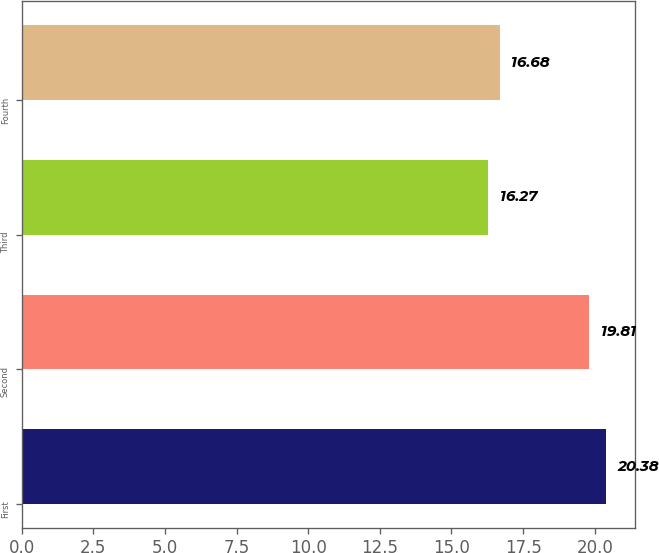Convert chart. <chart><loc_0><loc_0><loc_500><loc_500><bar_chart><fcel>First<fcel>Second<fcel>Third<fcel>Fourth<nl><fcel>20.38<fcel>19.81<fcel>16.27<fcel>16.68<nl></chart> 